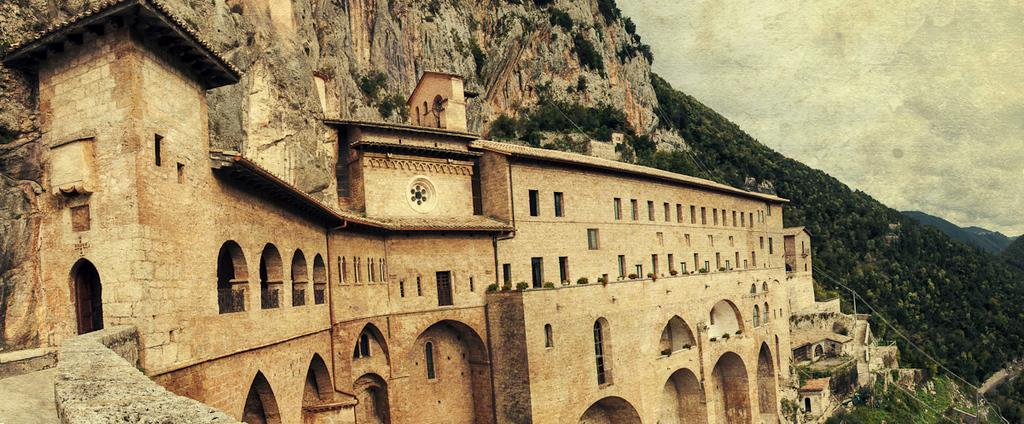What type of structure is present in the image? There is a building in the image. What type of natural vegetation is visible in the image? There are trees in the image. What type of geographical feature can be seen in the image? There is a mountain in the image. What is visible in the background of the image? The sky is visible in the background of the image. How much money is being exchanged in the image? There is no reference to money or any exchange of currency in the image. What type of clothing is being worn by the people in the image? There are no people visible in the image. What type of activity is being conducted in the image? There is no specific activity being conducted in the image; it features a building, trees, a mountain, and the sky. 